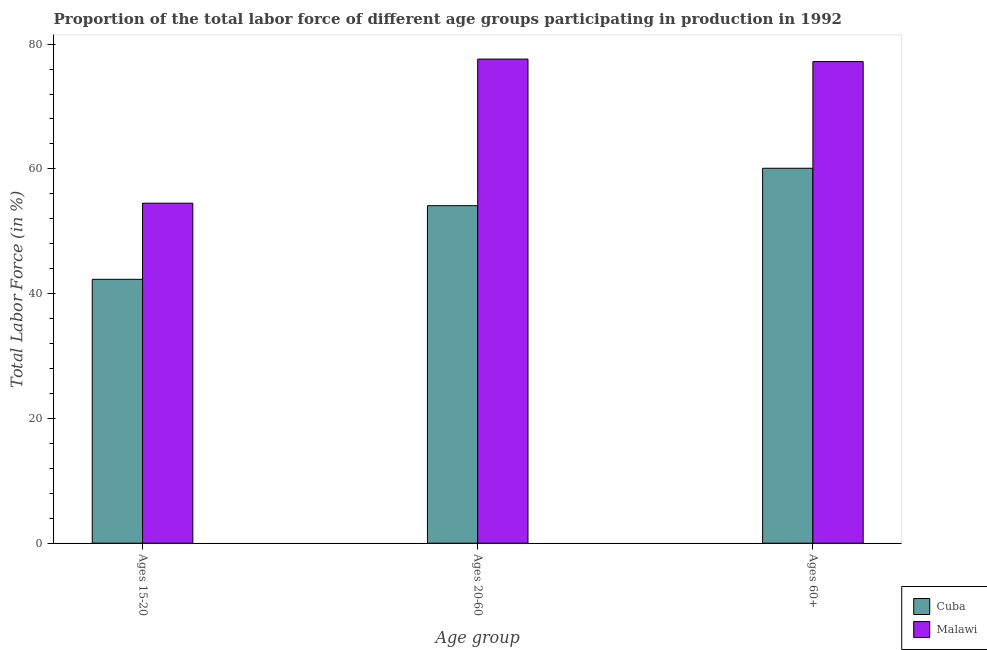Are the number of bars on each tick of the X-axis equal?
Your answer should be very brief. Yes. What is the label of the 1st group of bars from the left?
Make the answer very short. Ages 15-20. What is the percentage of labor force within the age group 15-20 in Malawi?
Ensure brevity in your answer.  54.5. Across all countries, what is the maximum percentage of labor force within the age group 20-60?
Your response must be concise. 77.6. Across all countries, what is the minimum percentage of labor force above age 60?
Ensure brevity in your answer.  60.1. In which country was the percentage of labor force above age 60 maximum?
Offer a very short reply. Malawi. In which country was the percentage of labor force within the age group 20-60 minimum?
Provide a short and direct response. Cuba. What is the total percentage of labor force above age 60 in the graph?
Give a very brief answer. 137.3. What is the difference between the percentage of labor force within the age group 20-60 in Cuba and that in Malawi?
Your answer should be compact. -23.5. What is the difference between the percentage of labor force within the age group 20-60 in Malawi and the percentage of labor force within the age group 15-20 in Cuba?
Your answer should be compact. 35.3. What is the average percentage of labor force above age 60 per country?
Ensure brevity in your answer.  68.65. What is the difference between the percentage of labor force above age 60 and percentage of labor force within the age group 15-20 in Cuba?
Ensure brevity in your answer.  17.8. In how many countries, is the percentage of labor force within the age group 20-60 greater than 16 %?
Your answer should be very brief. 2. What is the ratio of the percentage of labor force above age 60 in Malawi to that in Cuba?
Give a very brief answer. 1.28. Is the percentage of labor force within the age group 15-20 in Malawi less than that in Cuba?
Keep it short and to the point. No. What is the difference between the highest and the second highest percentage of labor force within the age group 15-20?
Make the answer very short. 12.2. What is the difference between the highest and the lowest percentage of labor force within the age group 20-60?
Your response must be concise. 23.5. In how many countries, is the percentage of labor force above age 60 greater than the average percentage of labor force above age 60 taken over all countries?
Your answer should be compact. 1. What does the 2nd bar from the left in Ages 20-60 represents?
Provide a short and direct response. Malawi. What does the 1st bar from the right in Ages 20-60 represents?
Your response must be concise. Malawi. Are all the bars in the graph horizontal?
Your answer should be very brief. No. How many countries are there in the graph?
Your response must be concise. 2. Are the values on the major ticks of Y-axis written in scientific E-notation?
Provide a short and direct response. No. Does the graph contain any zero values?
Your answer should be very brief. No. How are the legend labels stacked?
Give a very brief answer. Vertical. What is the title of the graph?
Keep it short and to the point. Proportion of the total labor force of different age groups participating in production in 1992. What is the label or title of the X-axis?
Provide a short and direct response. Age group. What is the label or title of the Y-axis?
Offer a terse response. Total Labor Force (in %). What is the Total Labor Force (in %) in Cuba in Ages 15-20?
Your answer should be compact. 42.3. What is the Total Labor Force (in %) of Malawi in Ages 15-20?
Offer a terse response. 54.5. What is the Total Labor Force (in %) in Cuba in Ages 20-60?
Offer a terse response. 54.1. What is the Total Labor Force (in %) in Malawi in Ages 20-60?
Give a very brief answer. 77.6. What is the Total Labor Force (in %) in Cuba in Ages 60+?
Ensure brevity in your answer.  60.1. What is the Total Labor Force (in %) of Malawi in Ages 60+?
Provide a short and direct response. 77.2. Across all Age group, what is the maximum Total Labor Force (in %) of Cuba?
Provide a succinct answer. 60.1. Across all Age group, what is the maximum Total Labor Force (in %) of Malawi?
Offer a very short reply. 77.6. Across all Age group, what is the minimum Total Labor Force (in %) in Cuba?
Your answer should be very brief. 42.3. Across all Age group, what is the minimum Total Labor Force (in %) in Malawi?
Give a very brief answer. 54.5. What is the total Total Labor Force (in %) in Cuba in the graph?
Provide a short and direct response. 156.5. What is the total Total Labor Force (in %) in Malawi in the graph?
Give a very brief answer. 209.3. What is the difference between the Total Labor Force (in %) in Malawi in Ages 15-20 and that in Ages 20-60?
Offer a very short reply. -23.1. What is the difference between the Total Labor Force (in %) in Cuba in Ages 15-20 and that in Ages 60+?
Your answer should be very brief. -17.8. What is the difference between the Total Labor Force (in %) of Malawi in Ages 15-20 and that in Ages 60+?
Offer a very short reply. -22.7. What is the difference between the Total Labor Force (in %) in Cuba in Ages 20-60 and that in Ages 60+?
Provide a succinct answer. -6. What is the difference between the Total Labor Force (in %) in Malawi in Ages 20-60 and that in Ages 60+?
Make the answer very short. 0.4. What is the difference between the Total Labor Force (in %) of Cuba in Ages 15-20 and the Total Labor Force (in %) of Malawi in Ages 20-60?
Offer a terse response. -35.3. What is the difference between the Total Labor Force (in %) of Cuba in Ages 15-20 and the Total Labor Force (in %) of Malawi in Ages 60+?
Make the answer very short. -34.9. What is the difference between the Total Labor Force (in %) in Cuba in Ages 20-60 and the Total Labor Force (in %) in Malawi in Ages 60+?
Offer a very short reply. -23.1. What is the average Total Labor Force (in %) of Cuba per Age group?
Your answer should be very brief. 52.17. What is the average Total Labor Force (in %) in Malawi per Age group?
Your answer should be compact. 69.77. What is the difference between the Total Labor Force (in %) in Cuba and Total Labor Force (in %) in Malawi in Ages 15-20?
Ensure brevity in your answer.  -12.2. What is the difference between the Total Labor Force (in %) of Cuba and Total Labor Force (in %) of Malawi in Ages 20-60?
Ensure brevity in your answer.  -23.5. What is the difference between the Total Labor Force (in %) of Cuba and Total Labor Force (in %) of Malawi in Ages 60+?
Make the answer very short. -17.1. What is the ratio of the Total Labor Force (in %) in Cuba in Ages 15-20 to that in Ages 20-60?
Provide a succinct answer. 0.78. What is the ratio of the Total Labor Force (in %) in Malawi in Ages 15-20 to that in Ages 20-60?
Your answer should be very brief. 0.7. What is the ratio of the Total Labor Force (in %) in Cuba in Ages 15-20 to that in Ages 60+?
Offer a very short reply. 0.7. What is the ratio of the Total Labor Force (in %) of Malawi in Ages 15-20 to that in Ages 60+?
Ensure brevity in your answer.  0.71. What is the ratio of the Total Labor Force (in %) in Cuba in Ages 20-60 to that in Ages 60+?
Ensure brevity in your answer.  0.9. What is the ratio of the Total Labor Force (in %) of Malawi in Ages 20-60 to that in Ages 60+?
Your response must be concise. 1.01. What is the difference between the highest and the lowest Total Labor Force (in %) in Malawi?
Provide a short and direct response. 23.1. 